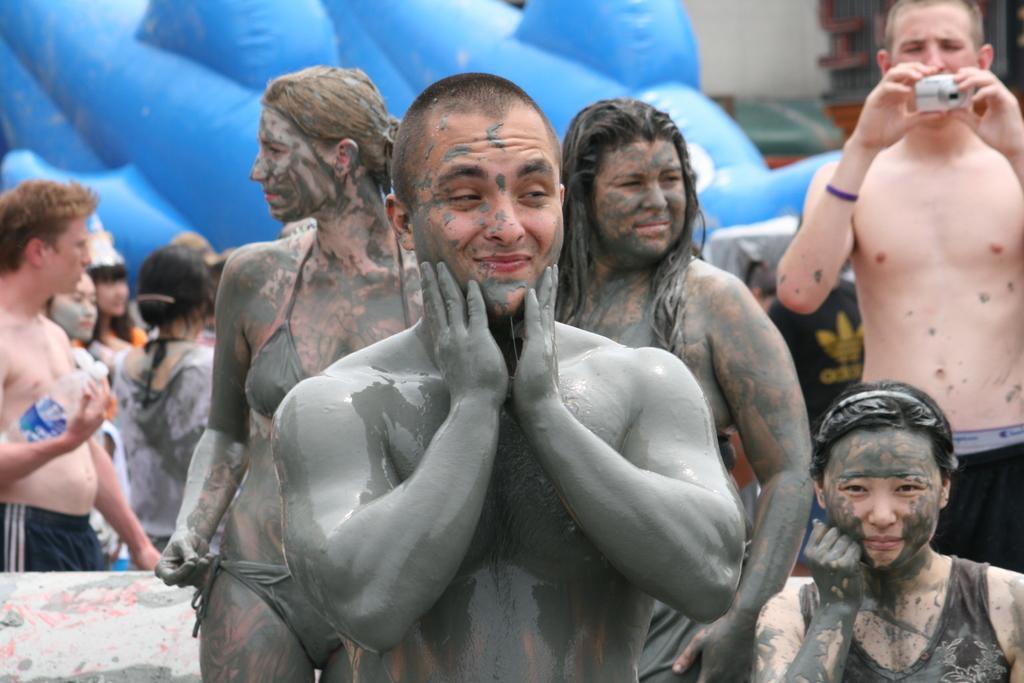How would you summarize this image in a sentence or two? In this picture there are group of people. On the left side of the image there is a person standing and holding the bottle. On the right side of the image there is a person standing and holding the device. 